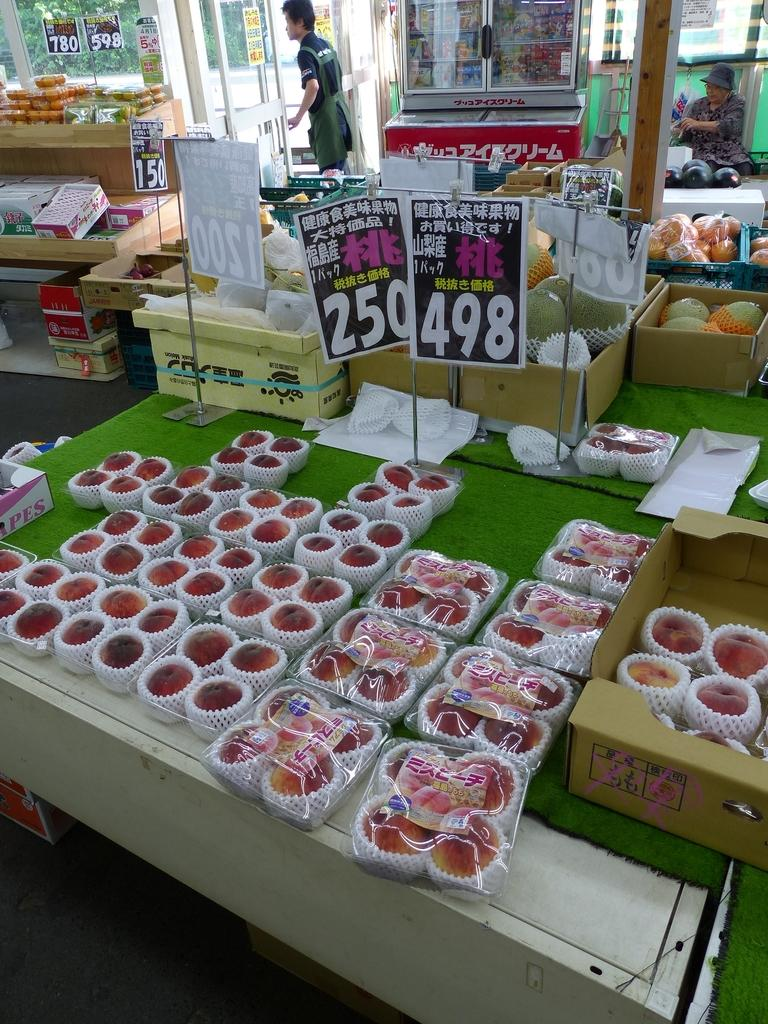<image>
Give a short and clear explanation of the subsequent image. A produce market showing prices of 250 and 498 for peaches in China. 